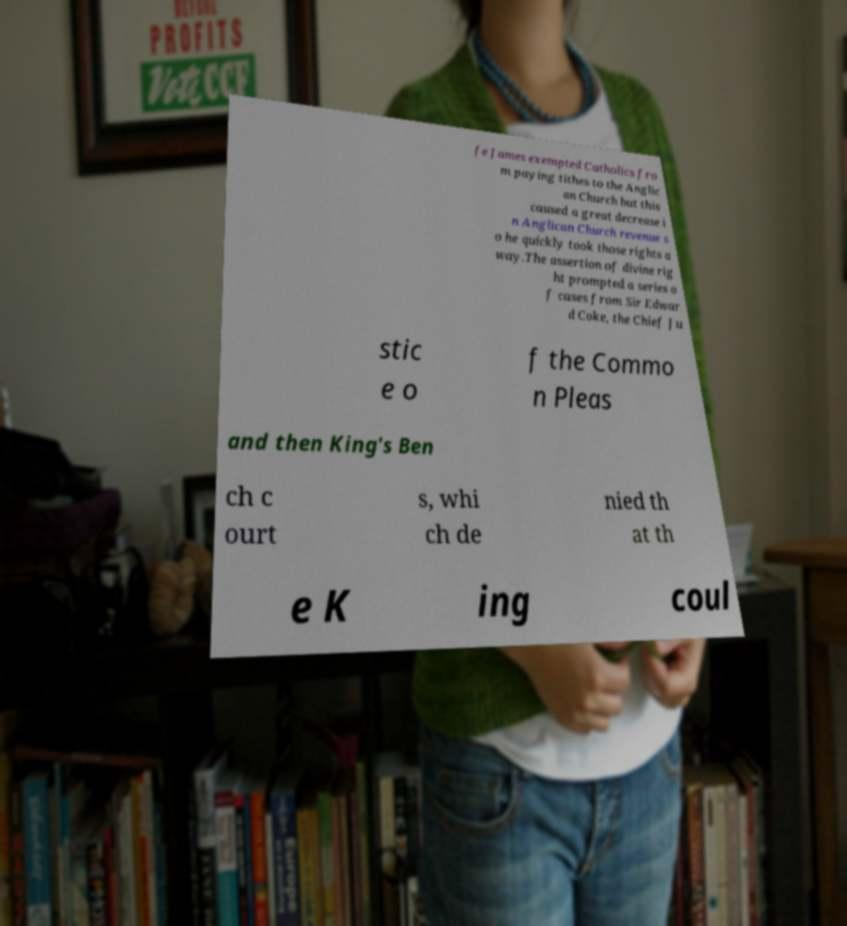For documentation purposes, I need the text within this image transcribed. Could you provide that? fe James exempted Catholics fro m paying tithes to the Anglic an Church but this caused a great decrease i n Anglican Church revenue s o he quickly took those rights a way.The assertion of divine rig ht prompted a series o f cases from Sir Edwar d Coke, the Chief Ju stic e o f the Commo n Pleas and then King's Ben ch c ourt s, whi ch de nied th at th e K ing coul 